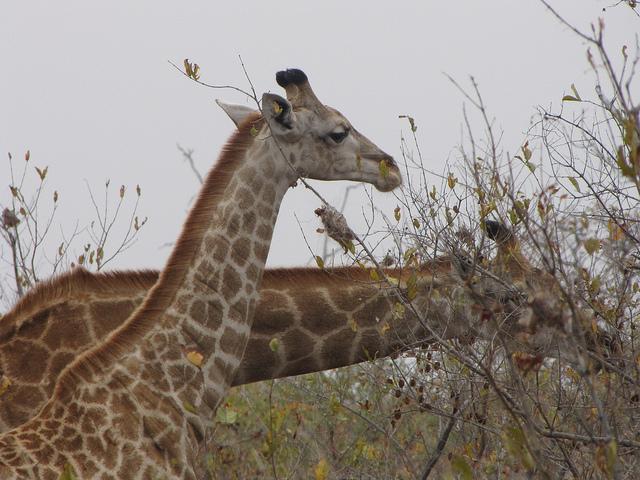How many giraffes are there?
Give a very brief answer. 2. 